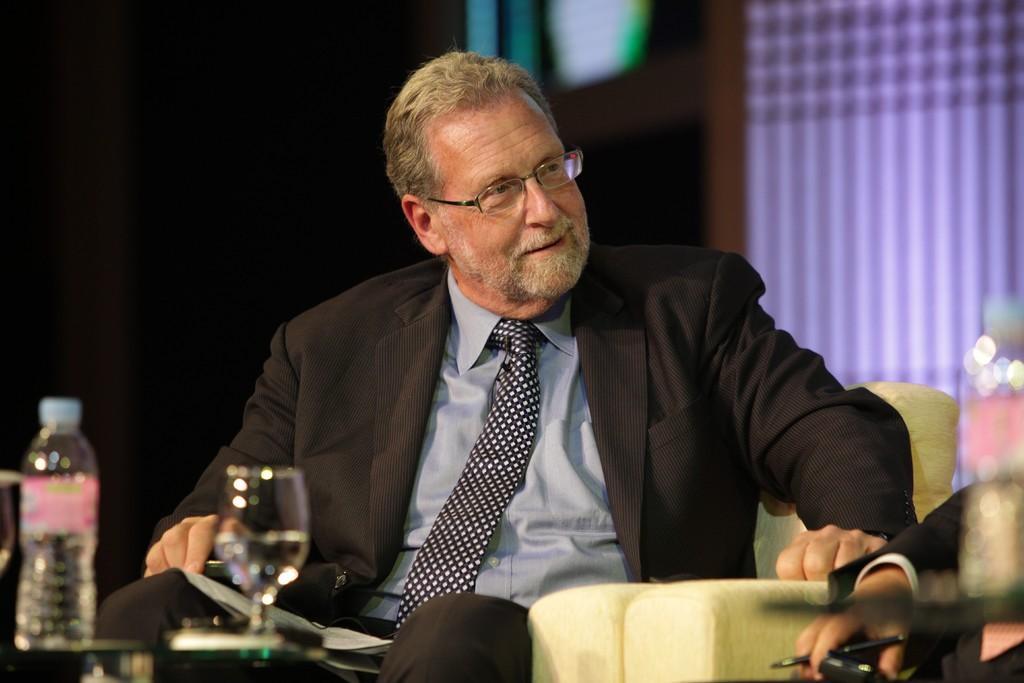How would you summarize this image in a sentence or two? In this image there is person sitting on the chair. There is a water bottle and a glass. 